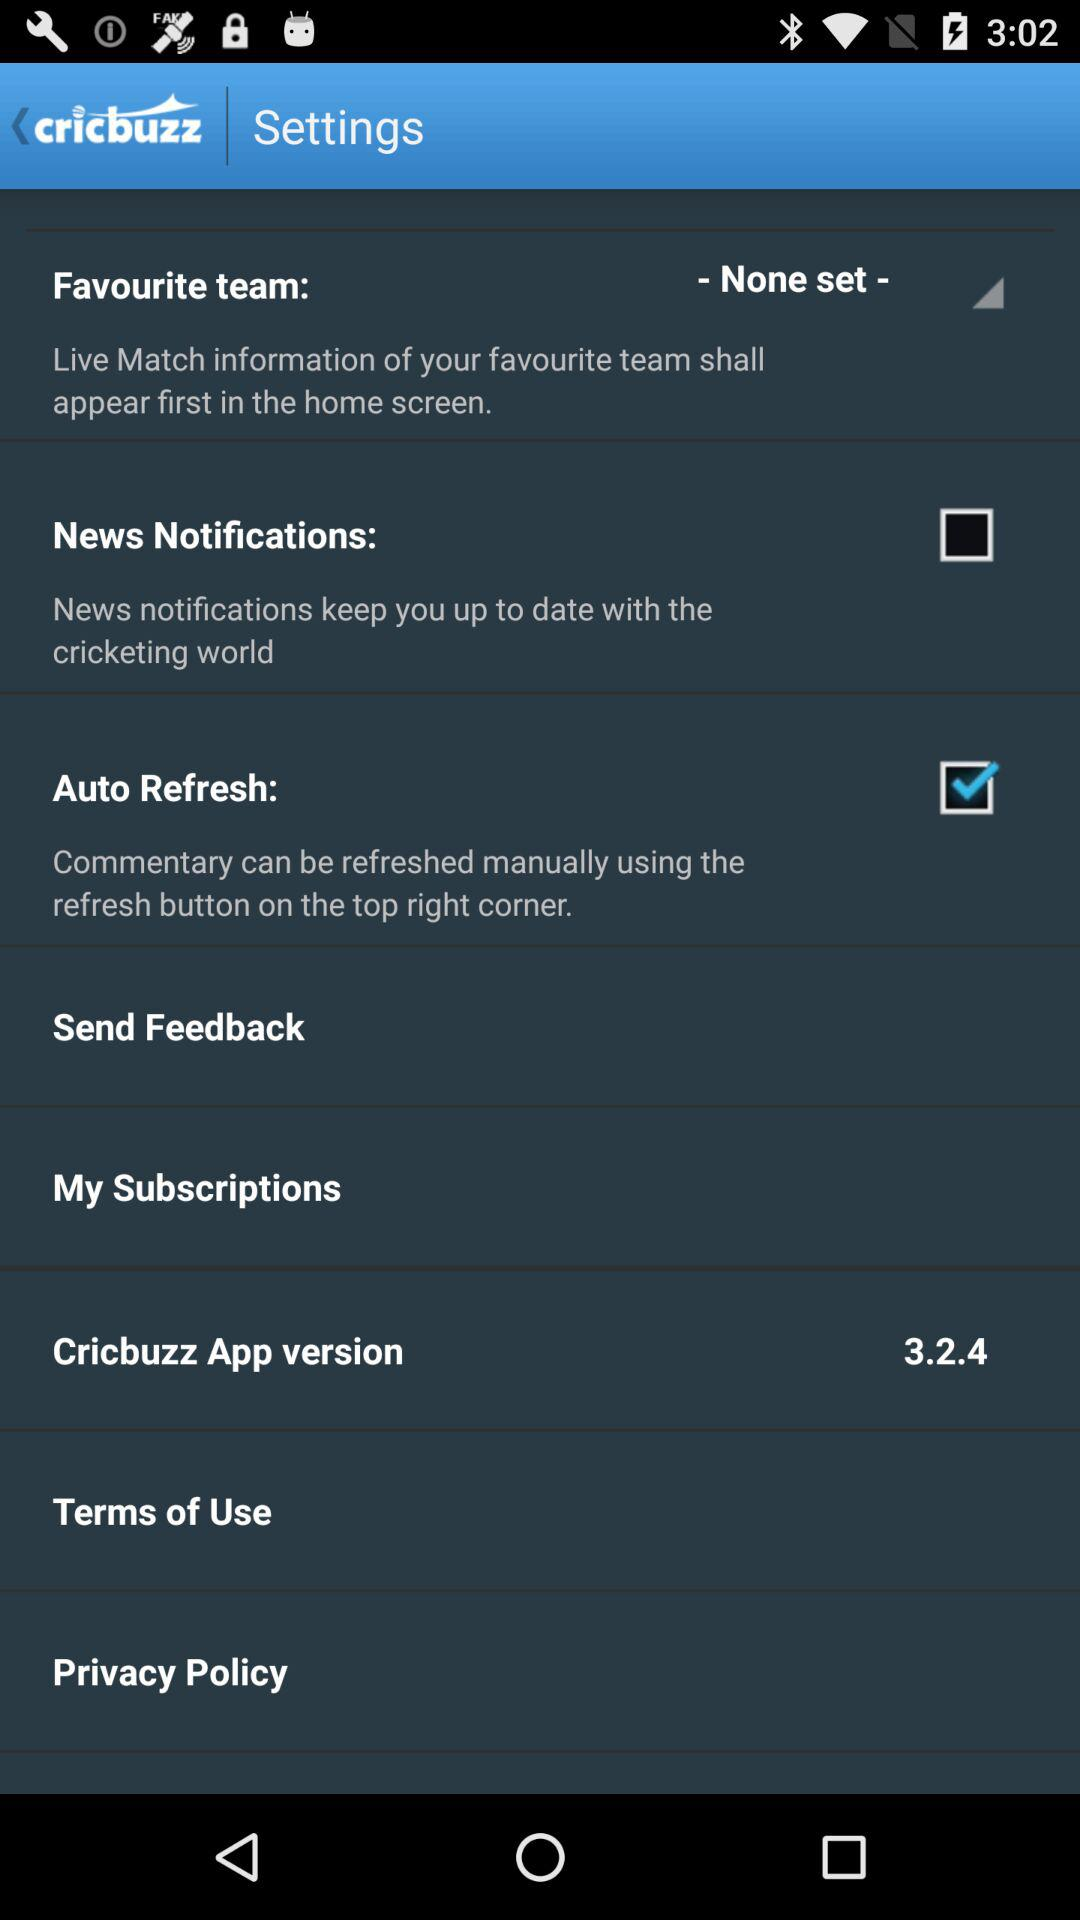Which setting is selected? The selected setting is "Auto Refresh". 